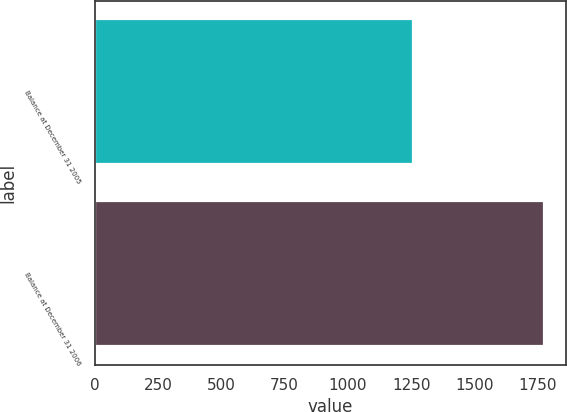Convert chart. <chart><loc_0><loc_0><loc_500><loc_500><bar_chart><fcel>Balance at December 31 2005<fcel>Balance at December 31 2006<nl><fcel>1258.6<fcel>1773.7<nl></chart> 